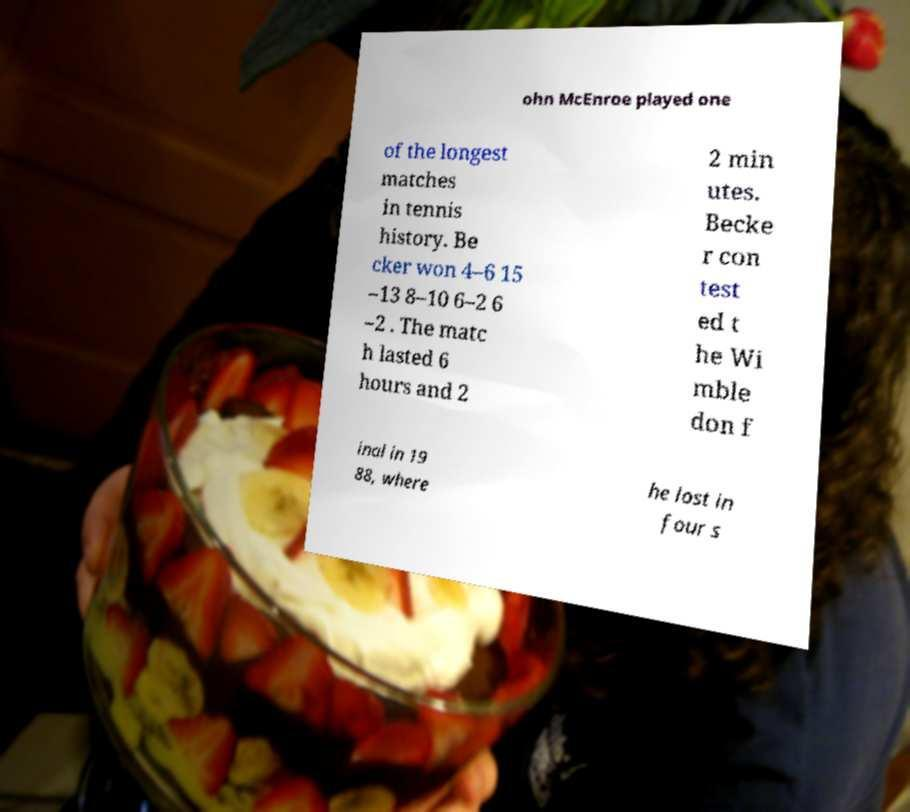Can you read and provide the text displayed in the image?This photo seems to have some interesting text. Can you extract and type it out for me? ohn McEnroe played one of the longest matches in tennis history. Be cker won 4–6 15 –13 8–10 6–2 6 –2 . The matc h lasted 6 hours and 2 2 min utes. Becke r con test ed t he Wi mble don f inal in 19 88, where he lost in four s 